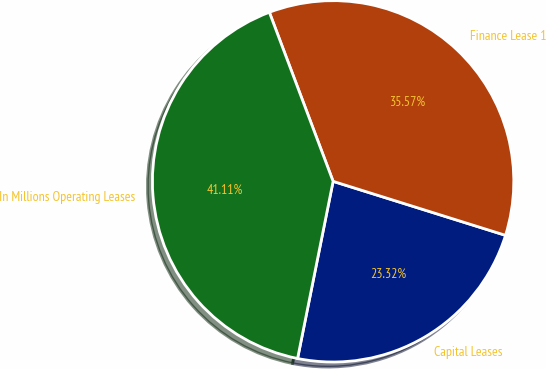<chart> <loc_0><loc_0><loc_500><loc_500><pie_chart><fcel>Capital Leases<fcel>Finance Lease 1<fcel>In Millions Operating Leases<nl><fcel>23.32%<fcel>35.57%<fcel>41.11%<nl></chart> 